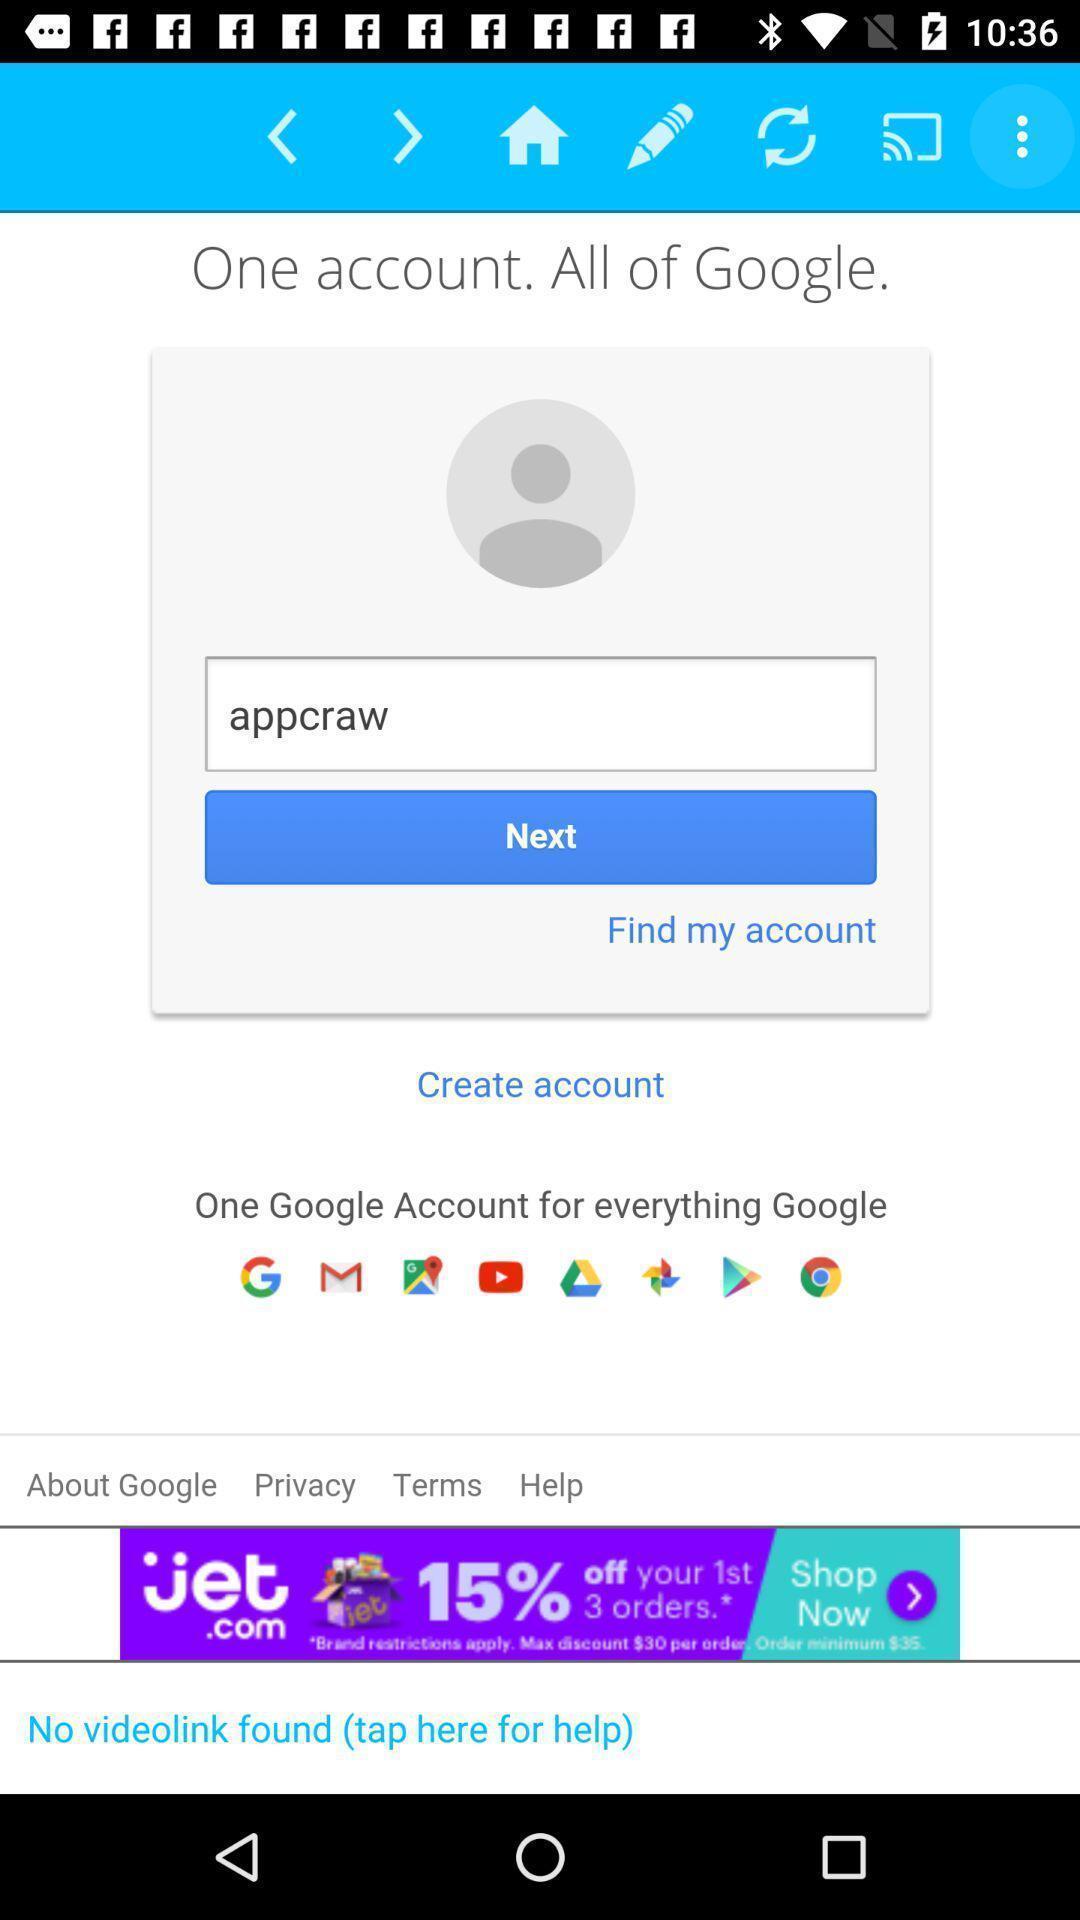What can you discern from this picture? Welcome page of a social app. 